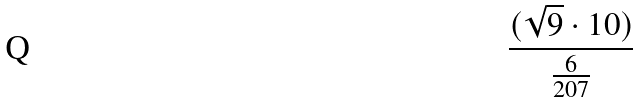<formula> <loc_0><loc_0><loc_500><loc_500>\frac { ( \sqrt { 9 } \cdot 1 0 ) } { \frac { 6 } { 2 0 7 } }</formula> 